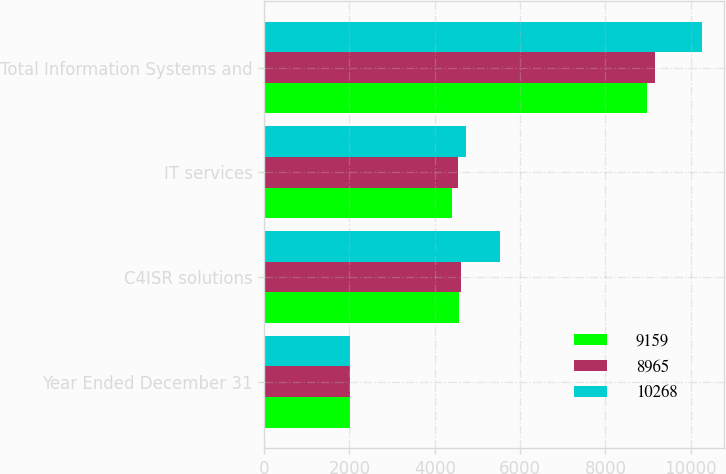<chart> <loc_0><loc_0><loc_500><loc_500><stacked_bar_chart><ecel><fcel>Year Ended December 31<fcel>C4ISR solutions<fcel>IT services<fcel>Total Information Systems and<nl><fcel>9159<fcel>2015<fcel>4571<fcel>4394<fcel>8965<nl><fcel>8965<fcel>2014<fcel>4610<fcel>4549<fcel>9159<nl><fcel>10268<fcel>2013<fcel>5534<fcel>4734<fcel>10268<nl></chart> 